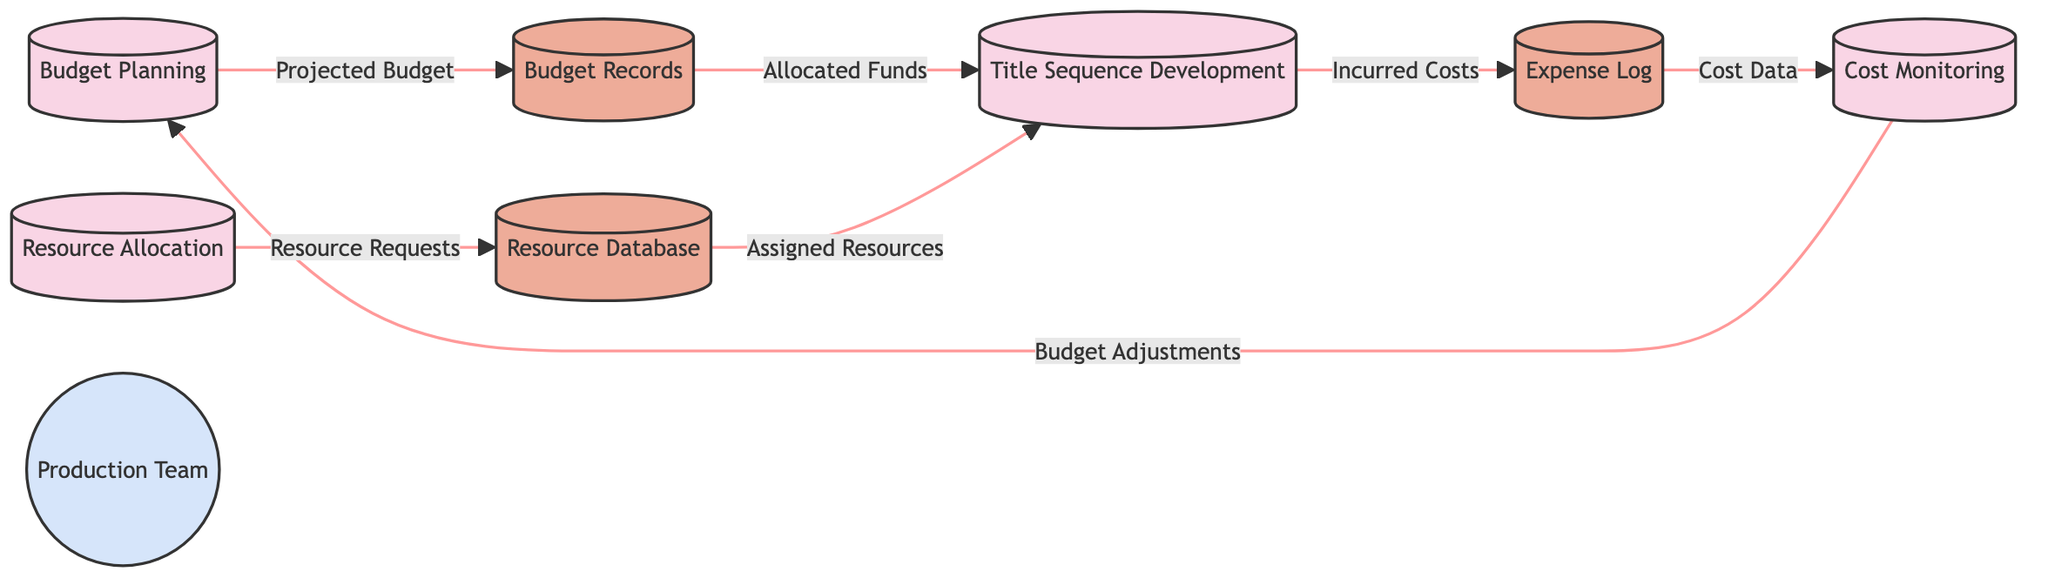What is the first process in the diagram? The diagram indicates that "Budget Planning" is the first process before any other activities take place, as it is the only one leading to the budget records.
Answer: Budget Planning How many data stores are present in the diagram? By counting the elements identified as data stores, we find three: Budget Records, Resource Database, and Expense Log.
Answer: 3 What type of data flows from "Budget Planning" to "Budget Records"? The arrow between "Budget Planning" and "Budget Records" is labeled "Projected Budget," signifying the type of data flowing in that direction.
Answer: Projected Budget What process do "Assigned Resources" belong to? The "Assigned Resources" flow is directed toward the "Title Sequence Development" process. Therefore, it is associated specifically with that process.
Answer: Title Sequence Development Which data store receives "Resource Requests"? The diagram shows "Resource Requests" flowing from the "Resource Allocation" process to the "Resource Database," indicating that is the data store that receives this information.
Answer: Resource Database What is the source of the "Cost Data"? The flow labeled "Cost Data" originates from the "Expense Log" data store and is directed toward the "Cost Monitoring" process, confirming the source.
Answer: Expense Log What process results in "Budget Adjustments"? "Budget Adjustments" are output from the "Cost Monitoring" process, which leads back to "Budget Planning," indicating that adjustments based on costs are considered there.
Answer: Cost Monitoring How many flows connect to the "Title Sequence Development" process? Looking at the data flows entering the "Title Sequence Development" process, we see two: "Allocated Funds" from Budget Records and "Assigned Resources" from the Resource Database.
Answer: 2 Which external entity is represented in the diagram? The diagram identifies "Production Team" as the external entity engaged in the overall processes shown, specifically in relation to budget and resource management.
Answer: Production Team 